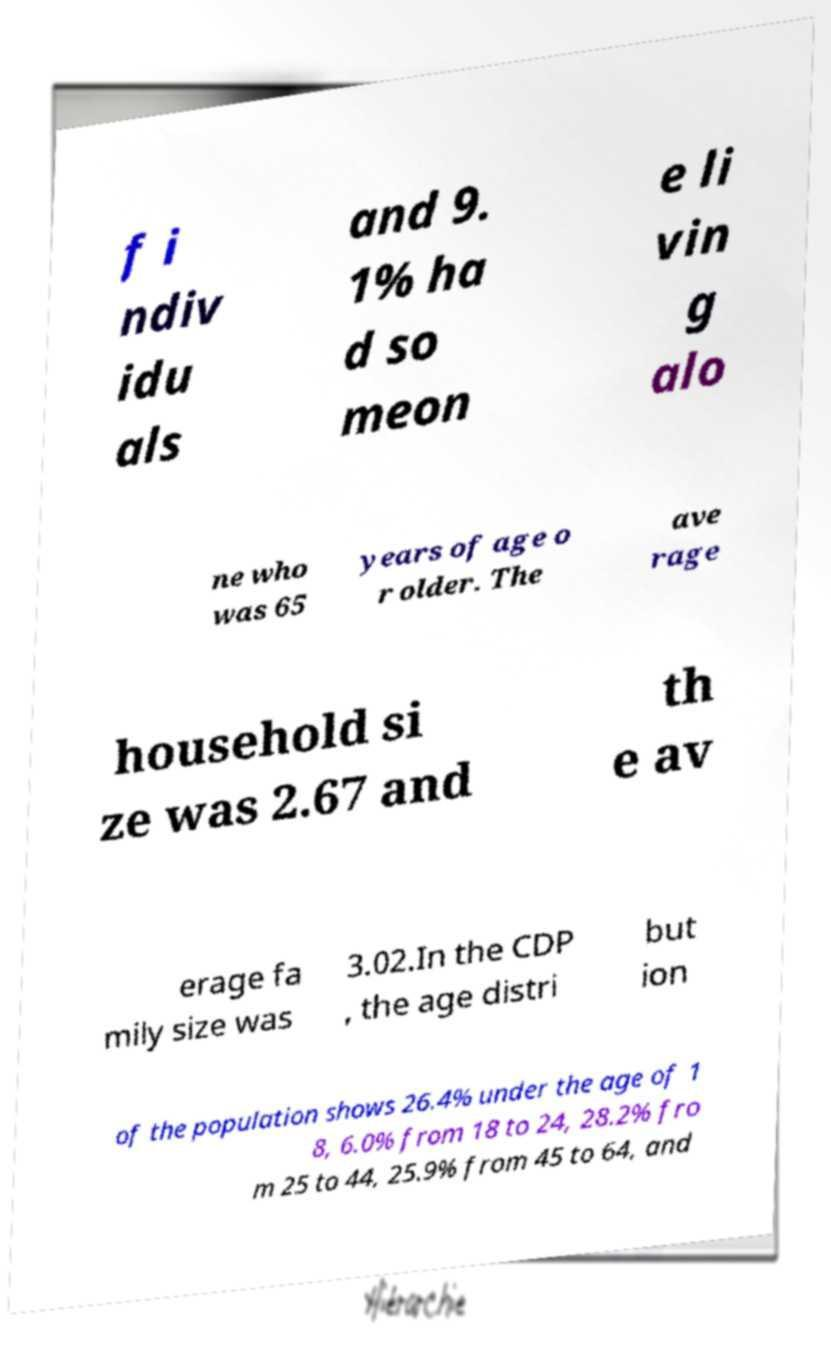Please read and relay the text visible in this image. What does it say? f i ndiv idu als and 9. 1% ha d so meon e li vin g alo ne who was 65 years of age o r older. The ave rage household si ze was 2.67 and th e av erage fa mily size was 3.02.In the CDP , the age distri but ion of the population shows 26.4% under the age of 1 8, 6.0% from 18 to 24, 28.2% fro m 25 to 44, 25.9% from 45 to 64, and 